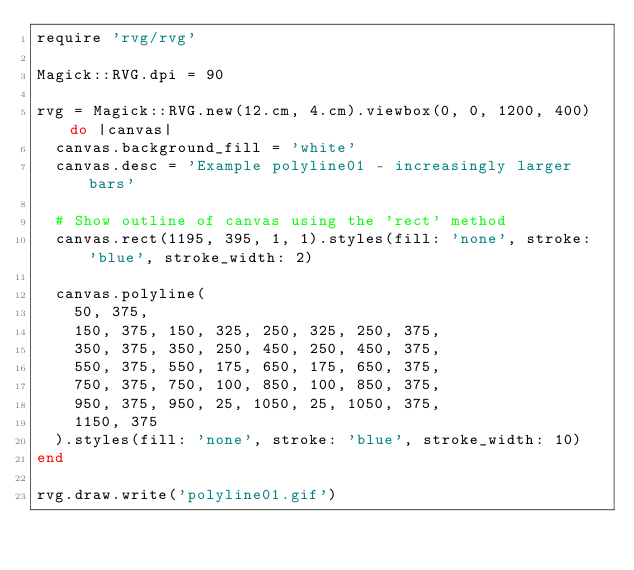Convert code to text. <code><loc_0><loc_0><loc_500><loc_500><_Ruby_>require 'rvg/rvg'

Magick::RVG.dpi = 90

rvg = Magick::RVG.new(12.cm, 4.cm).viewbox(0, 0, 1200, 400) do |canvas|
  canvas.background_fill = 'white'
  canvas.desc = 'Example polyline01 - increasingly larger bars'

  # Show outline of canvas using the 'rect' method
  canvas.rect(1195, 395, 1, 1).styles(fill: 'none', stroke: 'blue', stroke_width: 2)

  canvas.polyline(
    50, 375,
    150, 375, 150, 325, 250, 325, 250, 375,
    350, 375, 350, 250, 450, 250, 450, 375,
    550, 375, 550, 175, 650, 175, 650, 375,
    750, 375, 750, 100, 850, 100, 850, 375,
    950, 375, 950, 25, 1050, 25, 1050, 375,
    1150, 375
  ).styles(fill: 'none', stroke: 'blue', stroke_width: 10)
end

rvg.draw.write('polyline01.gif')
</code> 